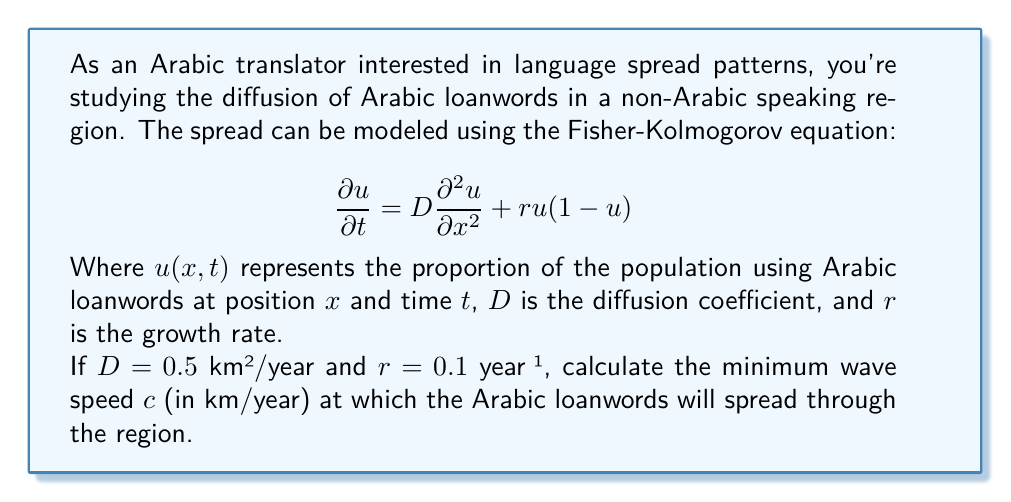Give your solution to this math problem. To solve this problem, we'll use the formula for the minimum wave speed in the Fisher-Kolmogorov equation:

$$c = 2\sqrt{Dr}$$

Where:
$c$ is the minimum wave speed
$D$ is the diffusion coefficient
$r$ is the growth rate

Step 1: Identify the given values
$D = 0.5$ km²/year
$r = 0.1$ year⁻¹

Step 2: Substitute these values into the formula
$$c = 2\sqrt{(0.5 \text{ km²/year})(0.1 \text{ year}⁻¹)}$$

Step 3: Simplify inside the square root
$$c = 2\sqrt{0.05 \text{ km²/year²}}$$

Step 4: Calculate the square root
$$c = 2(0.2236 \text{ km/year})$$

Step 5: Multiply by 2
$$c = 0.4472 \text{ km/year}$$

This result represents the minimum speed at which the wave of Arabic loanwords will spread through the region.
Answer: $c \approx 0.4472 \text{ km/year}$ 